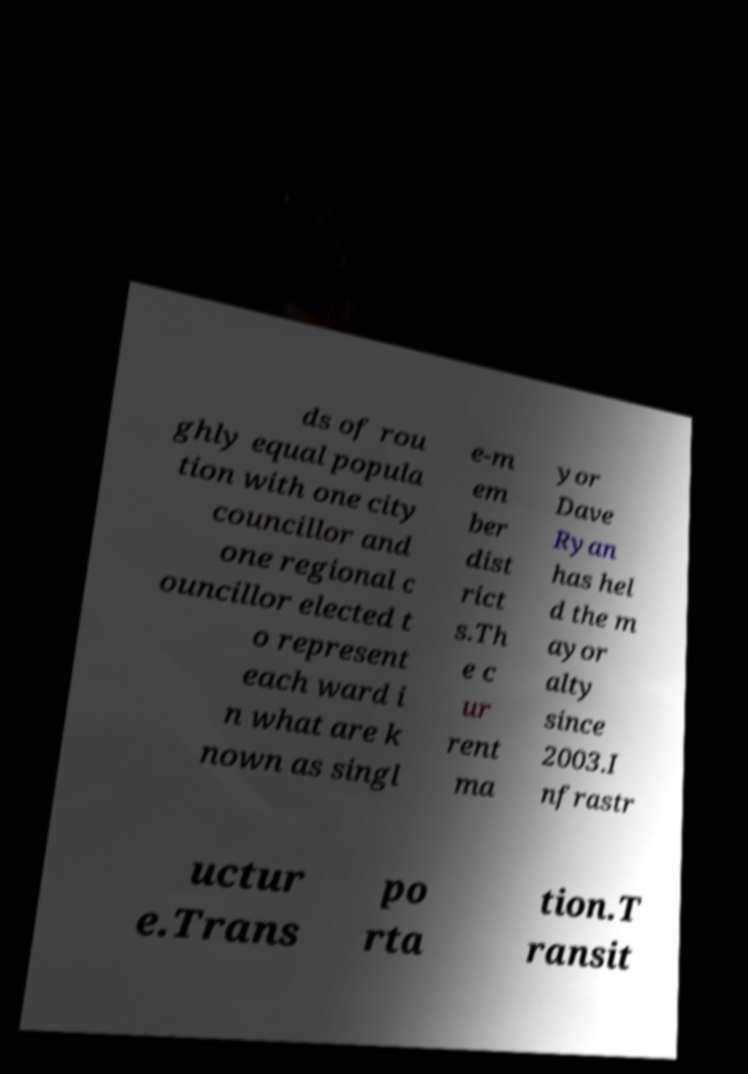For documentation purposes, I need the text within this image transcribed. Could you provide that? ds of rou ghly equal popula tion with one city councillor and one regional c ouncillor elected t o represent each ward i n what are k nown as singl e-m em ber dist rict s.Th e c ur rent ma yor Dave Ryan has hel d the m ayor alty since 2003.I nfrastr uctur e.Trans po rta tion.T ransit 